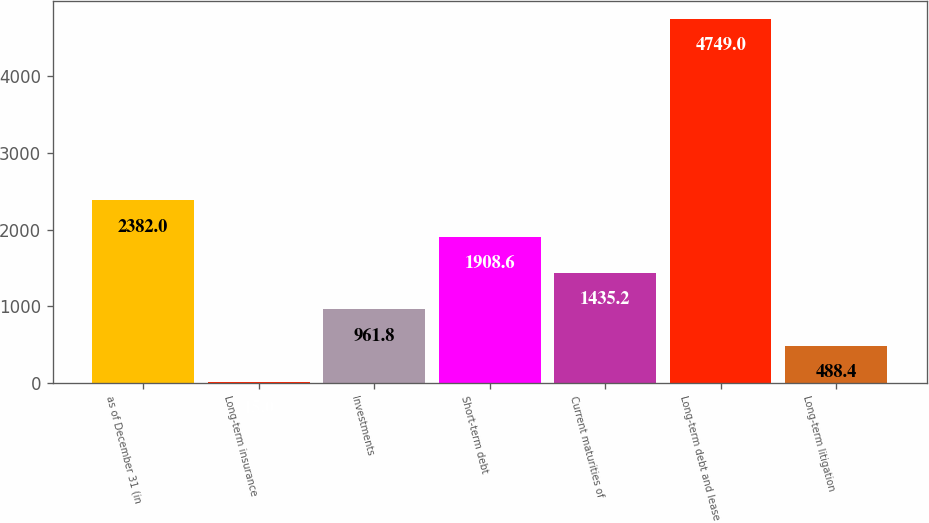<chart> <loc_0><loc_0><loc_500><loc_500><bar_chart><fcel>as of December 31 (in<fcel>Long-term insurance<fcel>Investments<fcel>Short-term debt<fcel>Current maturities of<fcel>Long-term debt and lease<fcel>Long-term litigation<nl><fcel>2382<fcel>15<fcel>961.8<fcel>1908.6<fcel>1435.2<fcel>4749<fcel>488.4<nl></chart> 